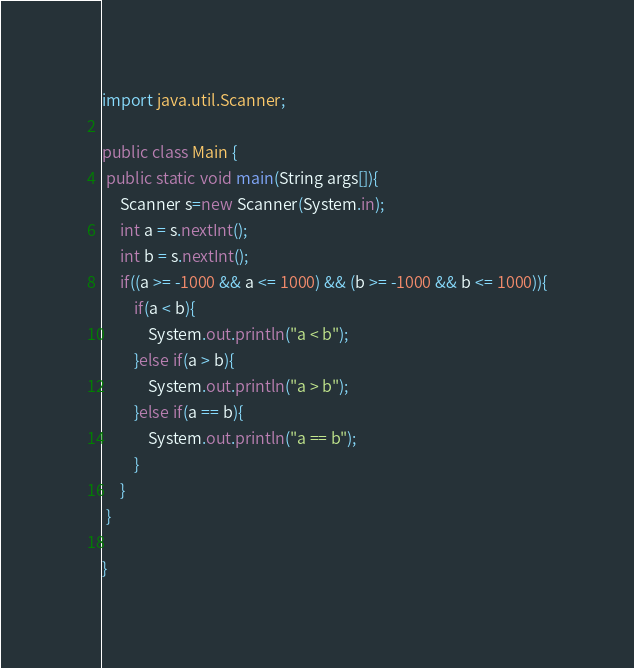<code> <loc_0><loc_0><loc_500><loc_500><_Java_>import java.util.Scanner;

public class Main {
 public static void main(String args[]){
	 Scanner s=new Scanner(System.in);
	 int a = s.nextInt();
	 int b = s.nextInt();
	 if((a >= -1000 && a <= 1000) && (b >= -1000 && b <= 1000)){
		 if(a < b){
			 System.out.println("a < b");
		 }else if(a > b){
			 System.out.println("a > b");
		 }else if(a == b){
			 System.out.println("a == b");
		 }
	 }
 }
 
}</code> 